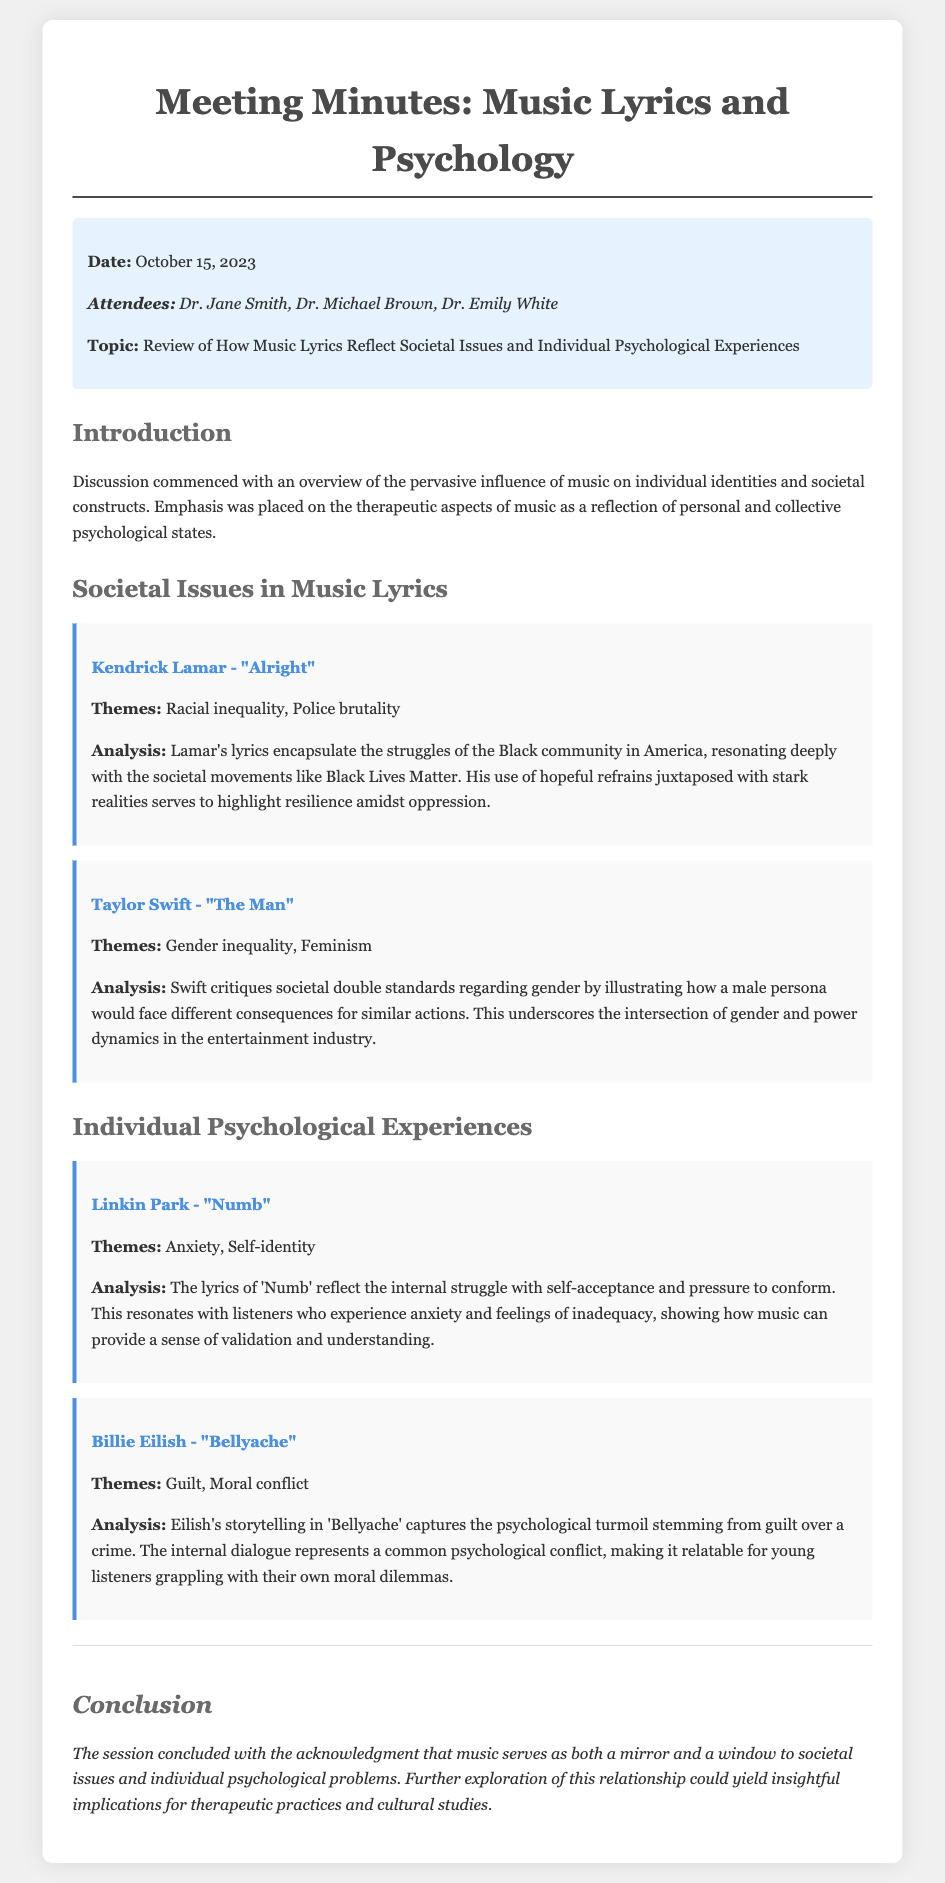What is the date of the meeting? The date of the meeting is explicitly stated in the document.
Answer: October 15, 2023 Who is one of the attendees? The document lists the attendees during the introductory section.
Answer: Dr. Jane Smith What is the main topic discussed? The main topic is highlighted in the introductory section of the document.
Answer: Review of How Music Lyrics Reflect Societal Issues and Individual Psychological Experiences Which song by Kendrick Lamar was analyzed? The song mentioned under societal issues is directly referenced in the document.
Answer: Alright What theme does Taylor Swift's song address? The theme of Swift's song is specified under her song analysis.
Answer: Gender inequality How does Linkin Park's "Numb" relate to individual experiences? The analysis section details the focus of the song.
Answer: Anxiety What is the conclusion about music's role? The conclusion section summarizes the overall findings discussed in the meeting.
Answer: A mirror and a window to societal issues and individual psychological problems Which artist's song illustrates guilt? The artist and song that captures this theme is located in the analysis section.
Answer: Billie Eilish - "Bellyache" What are the two societal issues addressed in Kendrick Lamar's lyrics? The document lists the themes identified in the analysis of Lamar's song.
Answer: Racial inequality, Police brutality 